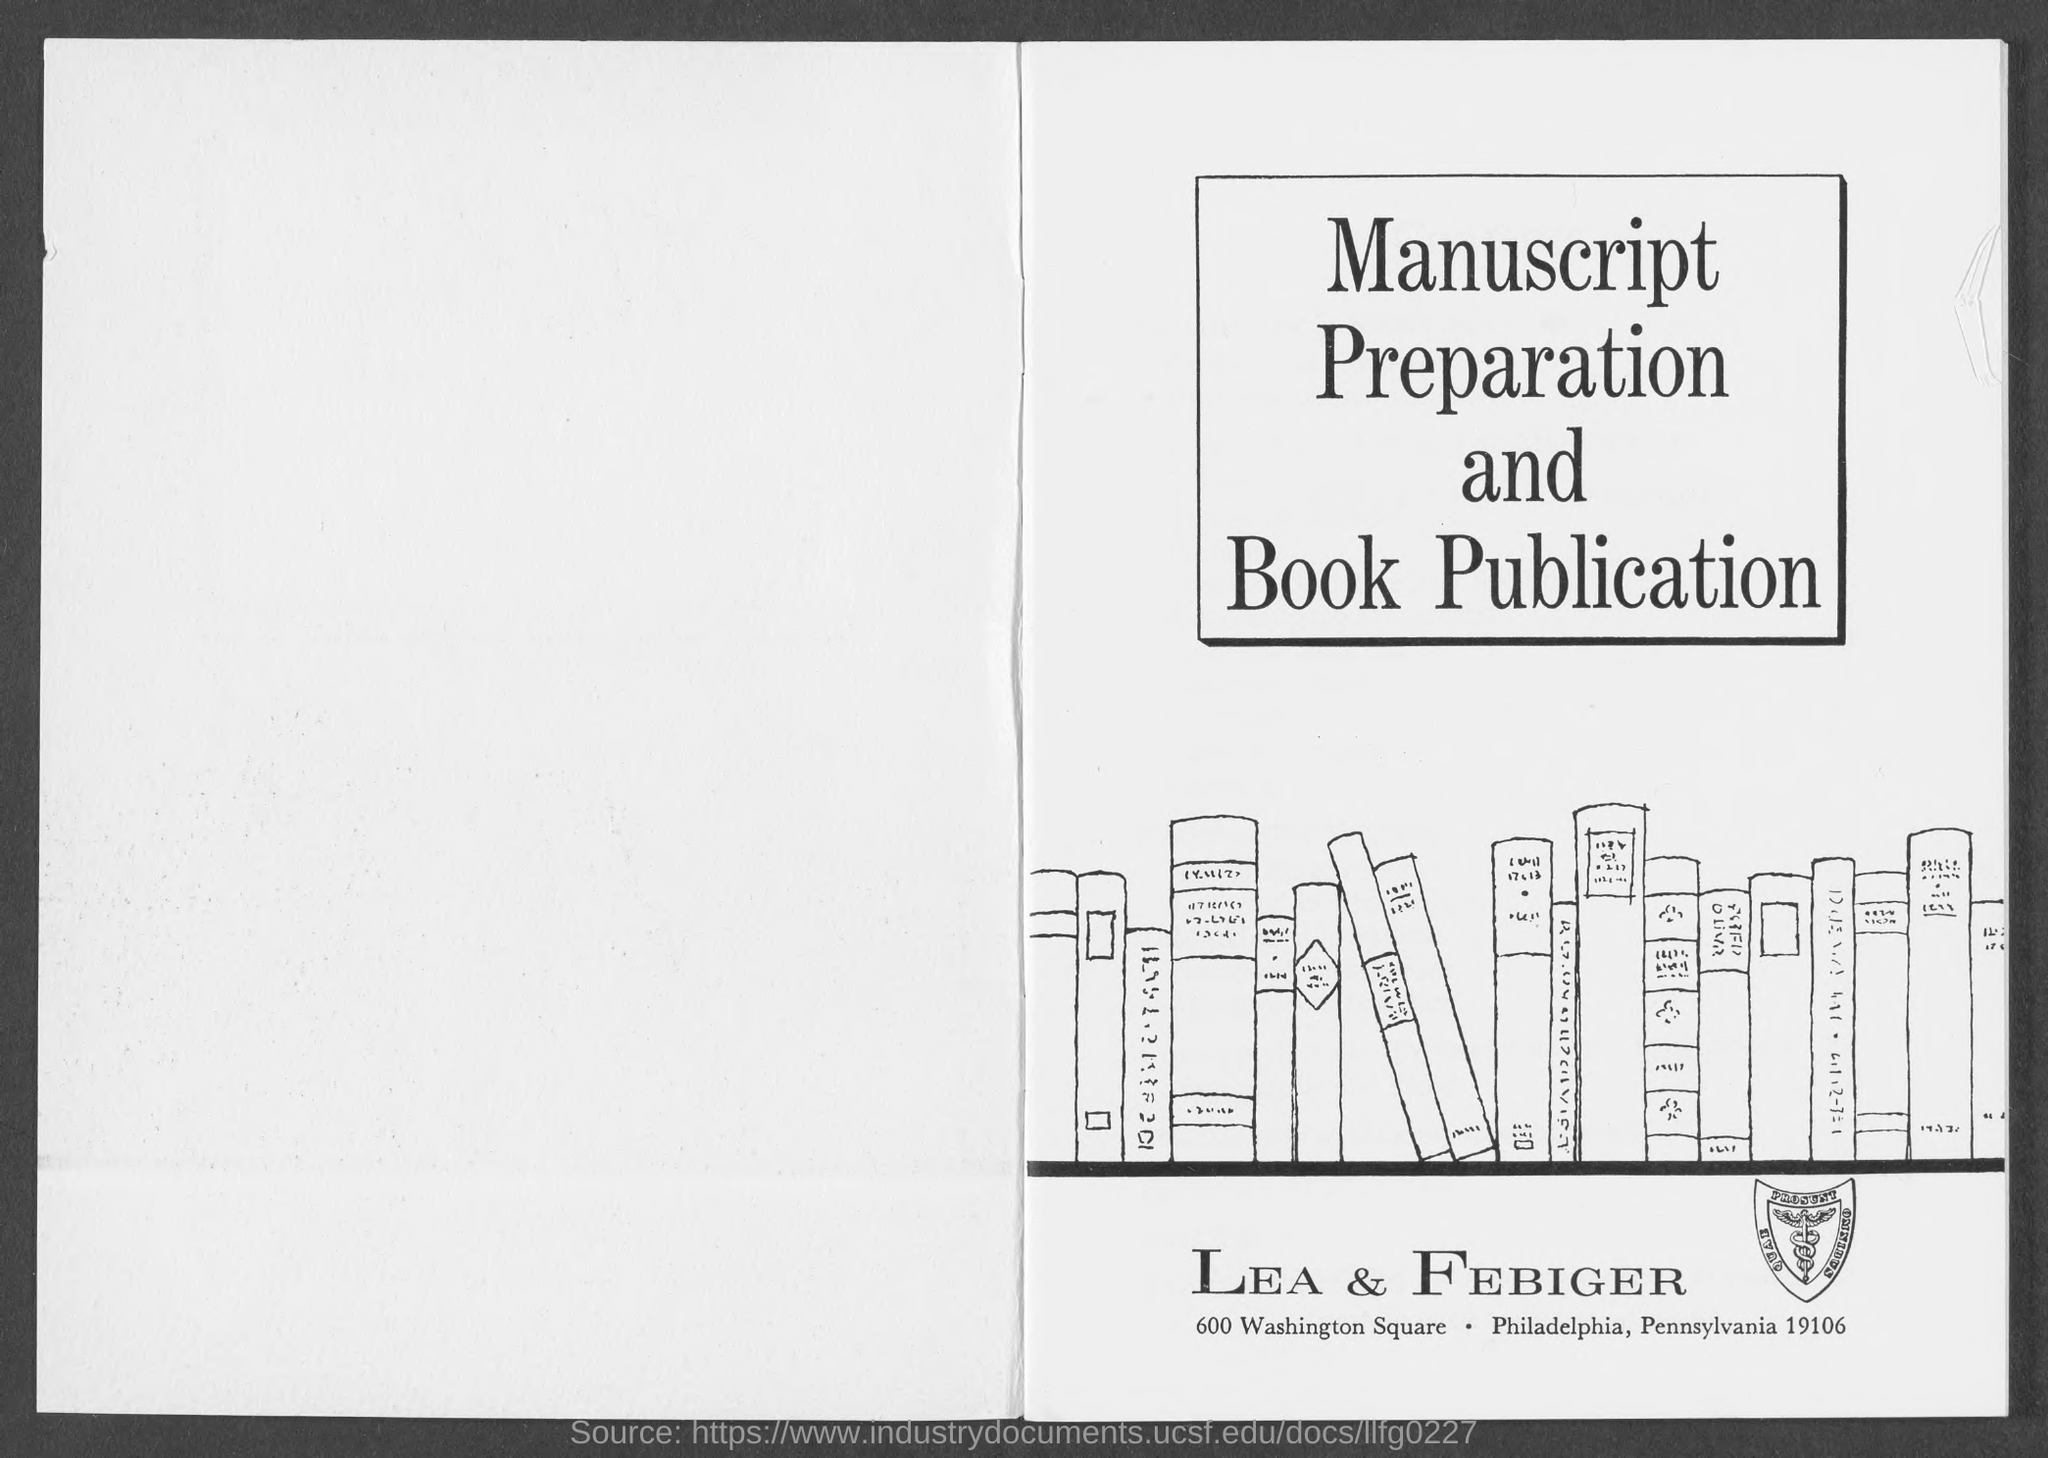In which city is lea & febiger at?
Provide a short and direct response. Philadelphia. 